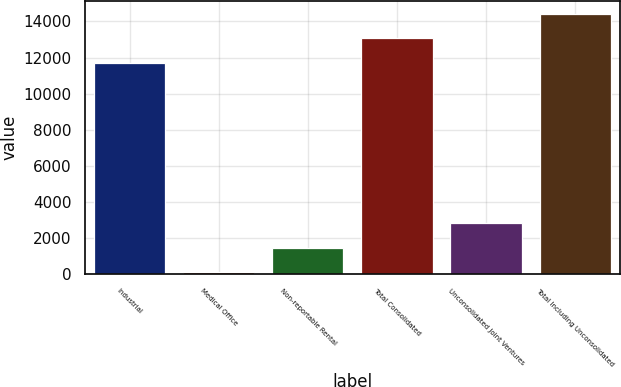<chart> <loc_0><loc_0><loc_500><loc_500><bar_chart><fcel>Industrial<fcel>Medical Office<fcel>Non-reportable Rental<fcel>Total Consolidated<fcel>Unconsolidated Joint Ventures<fcel>Total Including Unconsolidated<nl><fcel>11708<fcel>96<fcel>1453.4<fcel>13065.4<fcel>2810.8<fcel>14422.8<nl></chart> 